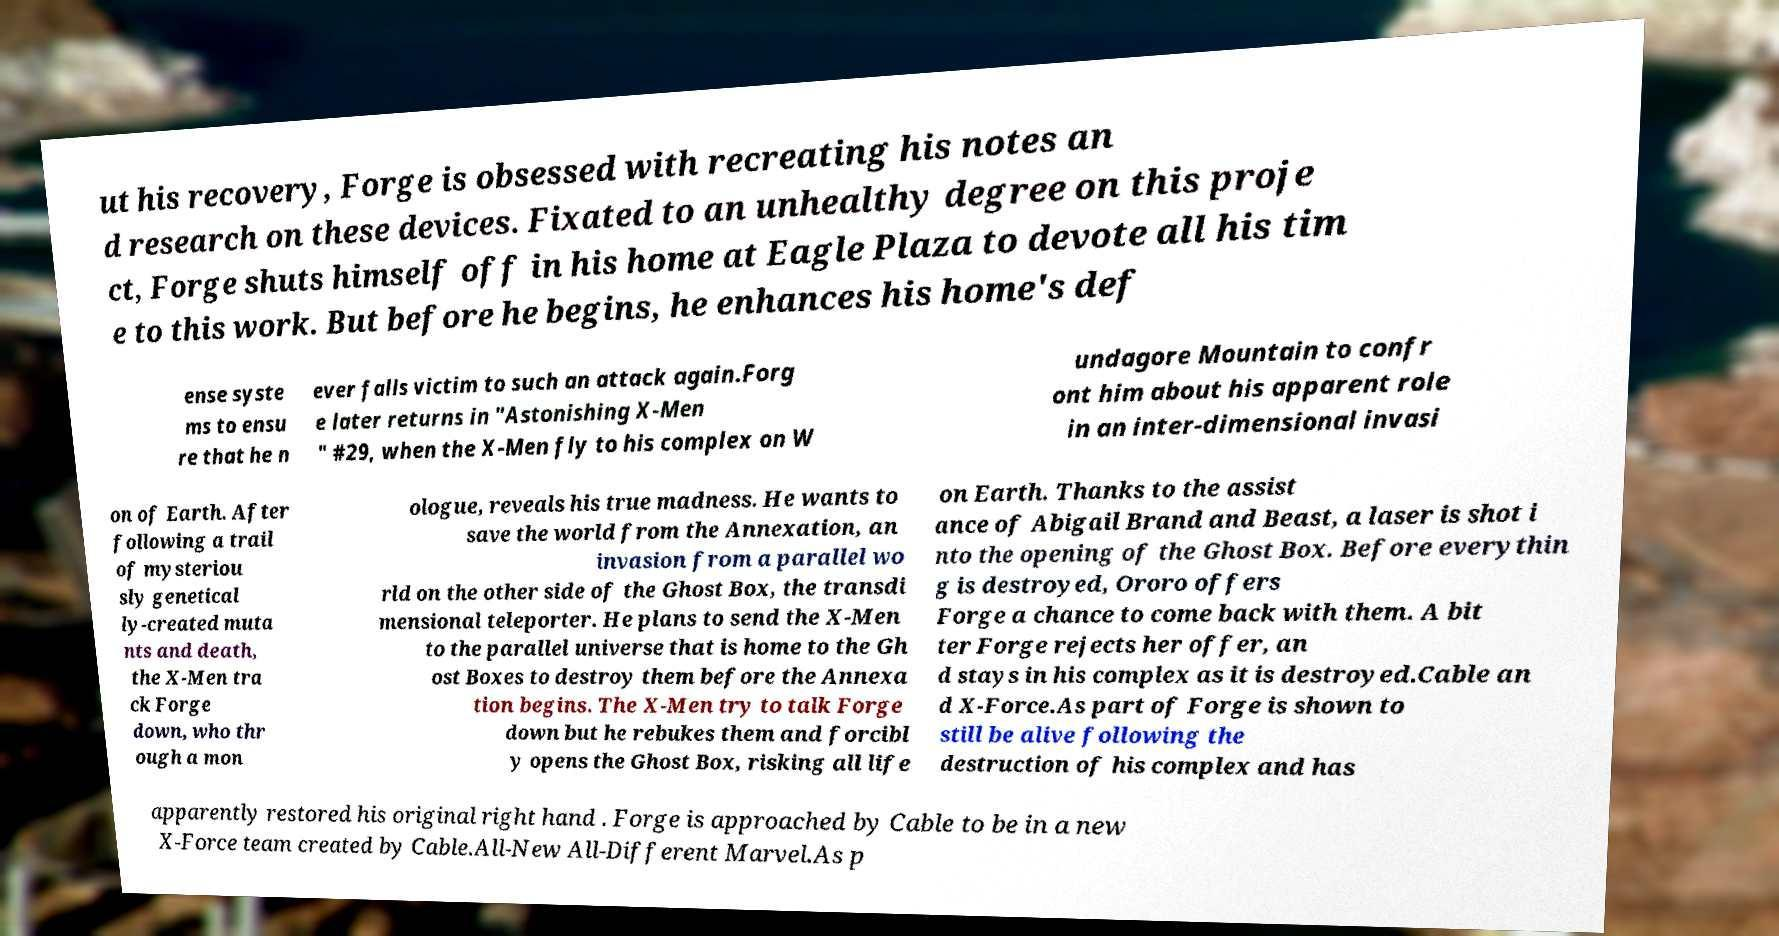Can you accurately transcribe the text from the provided image for me? ut his recovery, Forge is obsessed with recreating his notes an d research on these devices. Fixated to an unhealthy degree on this proje ct, Forge shuts himself off in his home at Eagle Plaza to devote all his tim e to this work. But before he begins, he enhances his home's def ense syste ms to ensu re that he n ever falls victim to such an attack again.Forg e later returns in "Astonishing X-Men " #29, when the X-Men fly to his complex on W undagore Mountain to confr ont him about his apparent role in an inter-dimensional invasi on of Earth. After following a trail of mysteriou sly genetical ly-created muta nts and death, the X-Men tra ck Forge down, who thr ough a mon ologue, reveals his true madness. He wants to save the world from the Annexation, an invasion from a parallel wo rld on the other side of the Ghost Box, the transdi mensional teleporter. He plans to send the X-Men to the parallel universe that is home to the Gh ost Boxes to destroy them before the Annexa tion begins. The X-Men try to talk Forge down but he rebukes them and forcibl y opens the Ghost Box, risking all life on Earth. Thanks to the assist ance of Abigail Brand and Beast, a laser is shot i nto the opening of the Ghost Box. Before everythin g is destroyed, Ororo offers Forge a chance to come back with them. A bit ter Forge rejects her offer, an d stays in his complex as it is destroyed.Cable an d X-Force.As part of Forge is shown to still be alive following the destruction of his complex and has apparently restored his original right hand . Forge is approached by Cable to be in a new X-Force team created by Cable.All-New All-Different Marvel.As p 